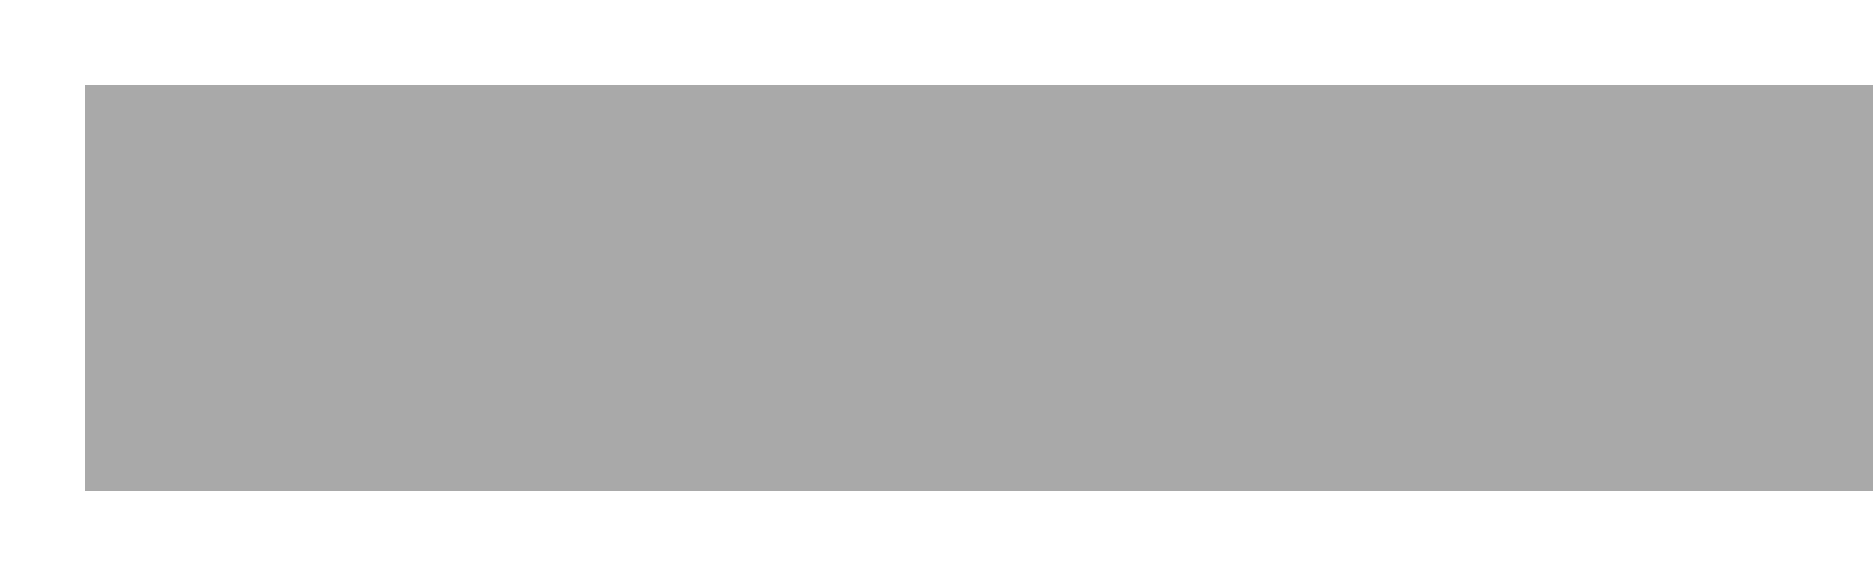What is the name of the sender? The sender of the letter is identified at the top of the document as Hans Müller.
Answer: Hans Müller What is the address of the sender? The address of the sender is located below the name and consists of Kaiserstraße 14, 60311 Frankfurt am Main, Germany.
Answer: Kaiserstraße 14, 60311 Frankfurt am Main, Germany What is the date on the document? The date is prominently displayed in the center of the document, indicating the time the letter was written.
Answer: October 15, 1985 What is the recipient's name? The recipient's name is given in a larger font and prominent display, identified as Jana Schmidt.
Answer: Jana Schmidt What city is the recipient located in? The address of the recipient includes the city, which is part of their address.
Answer: Berlin What color is used for the recipient's name? The document specifies the color used for the recipient's name, highlighting it visually.
Answer: westgermangold What is the purpose of this document? The context of the document indicates it is a correspondence regarding a potential art transaction.
Answer: Correspondence about purchasing art How many times does the name "Jana" appear in the document? The name "Jana" is mentioned in the recipient's address section.
Answer: Once What is the significance of the color scheme used in the document? The color scheme combines gray and gold, representing the geographical and cultural contrast between East and West Germany.
Answer: Cultural contrast What type of document is this? The format and layout indicate this is a formal letter, often used for professional or business communication.
Answer: Letter 